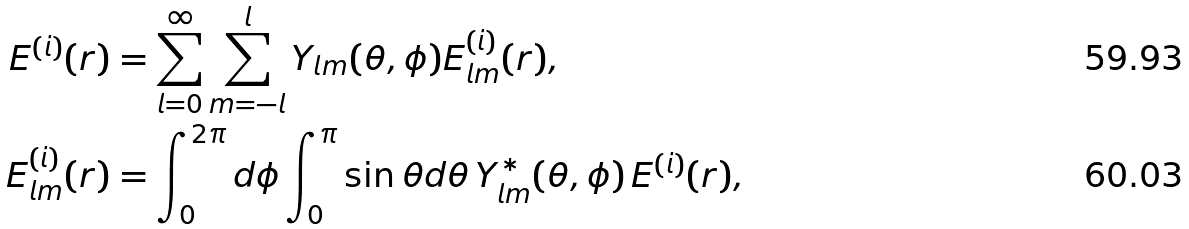<formula> <loc_0><loc_0><loc_500><loc_500>E ^ { ( i ) } ( { r } ) & = \sum _ { l = 0 } ^ { \infty } \sum _ { m = - l } ^ { l } Y _ { l m } ( \theta , \phi ) E ^ { ( i ) } _ { l m } ( r ) , \\ E ^ { ( i ) } _ { l m } ( r ) & = \int _ { 0 } ^ { 2 \pi } d \phi \int _ { 0 } ^ { \pi } \sin \theta d \theta \, Y _ { l m } ^ { * } ( \theta , \phi ) \, E ^ { ( i ) } ( { r } ) ,</formula> 